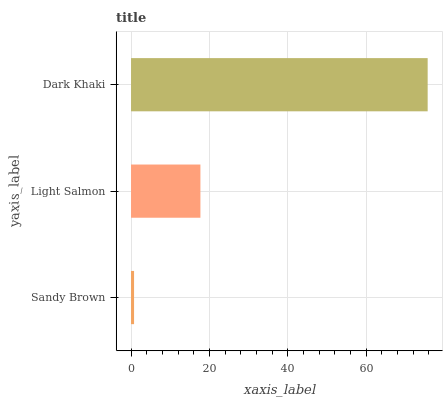Is Sandy Brown the minimum?
Answer yes or no. Yes. Is Dark Khaki the maximum?
Answer yes or no. Yes. Is Light Salmon the minimum?
Answer yes or no. No. Is Light Salmon the maximum?
Answer yes or no. No. Is Light Salmon greater than Sandy Brown?
Answer yes or no. Yes. Is Sandy Brown less than Light Salmon?
Answer yes or no. Yes. Is Sandy Brown greater than Light Salmon?
Answer yes or no. No. Is Light Salmon less than Sandy Brown?
Answer yes or no. No. Is Light Salmon the high median?
Answer yes or no. Yes. Is Light Salmon the low median?
Answer yes or no. Yes. Is Sandy Brown the high median?
Answer yes or no. No. Is Dark Khaki the low median?
Answer yes or no. No. 